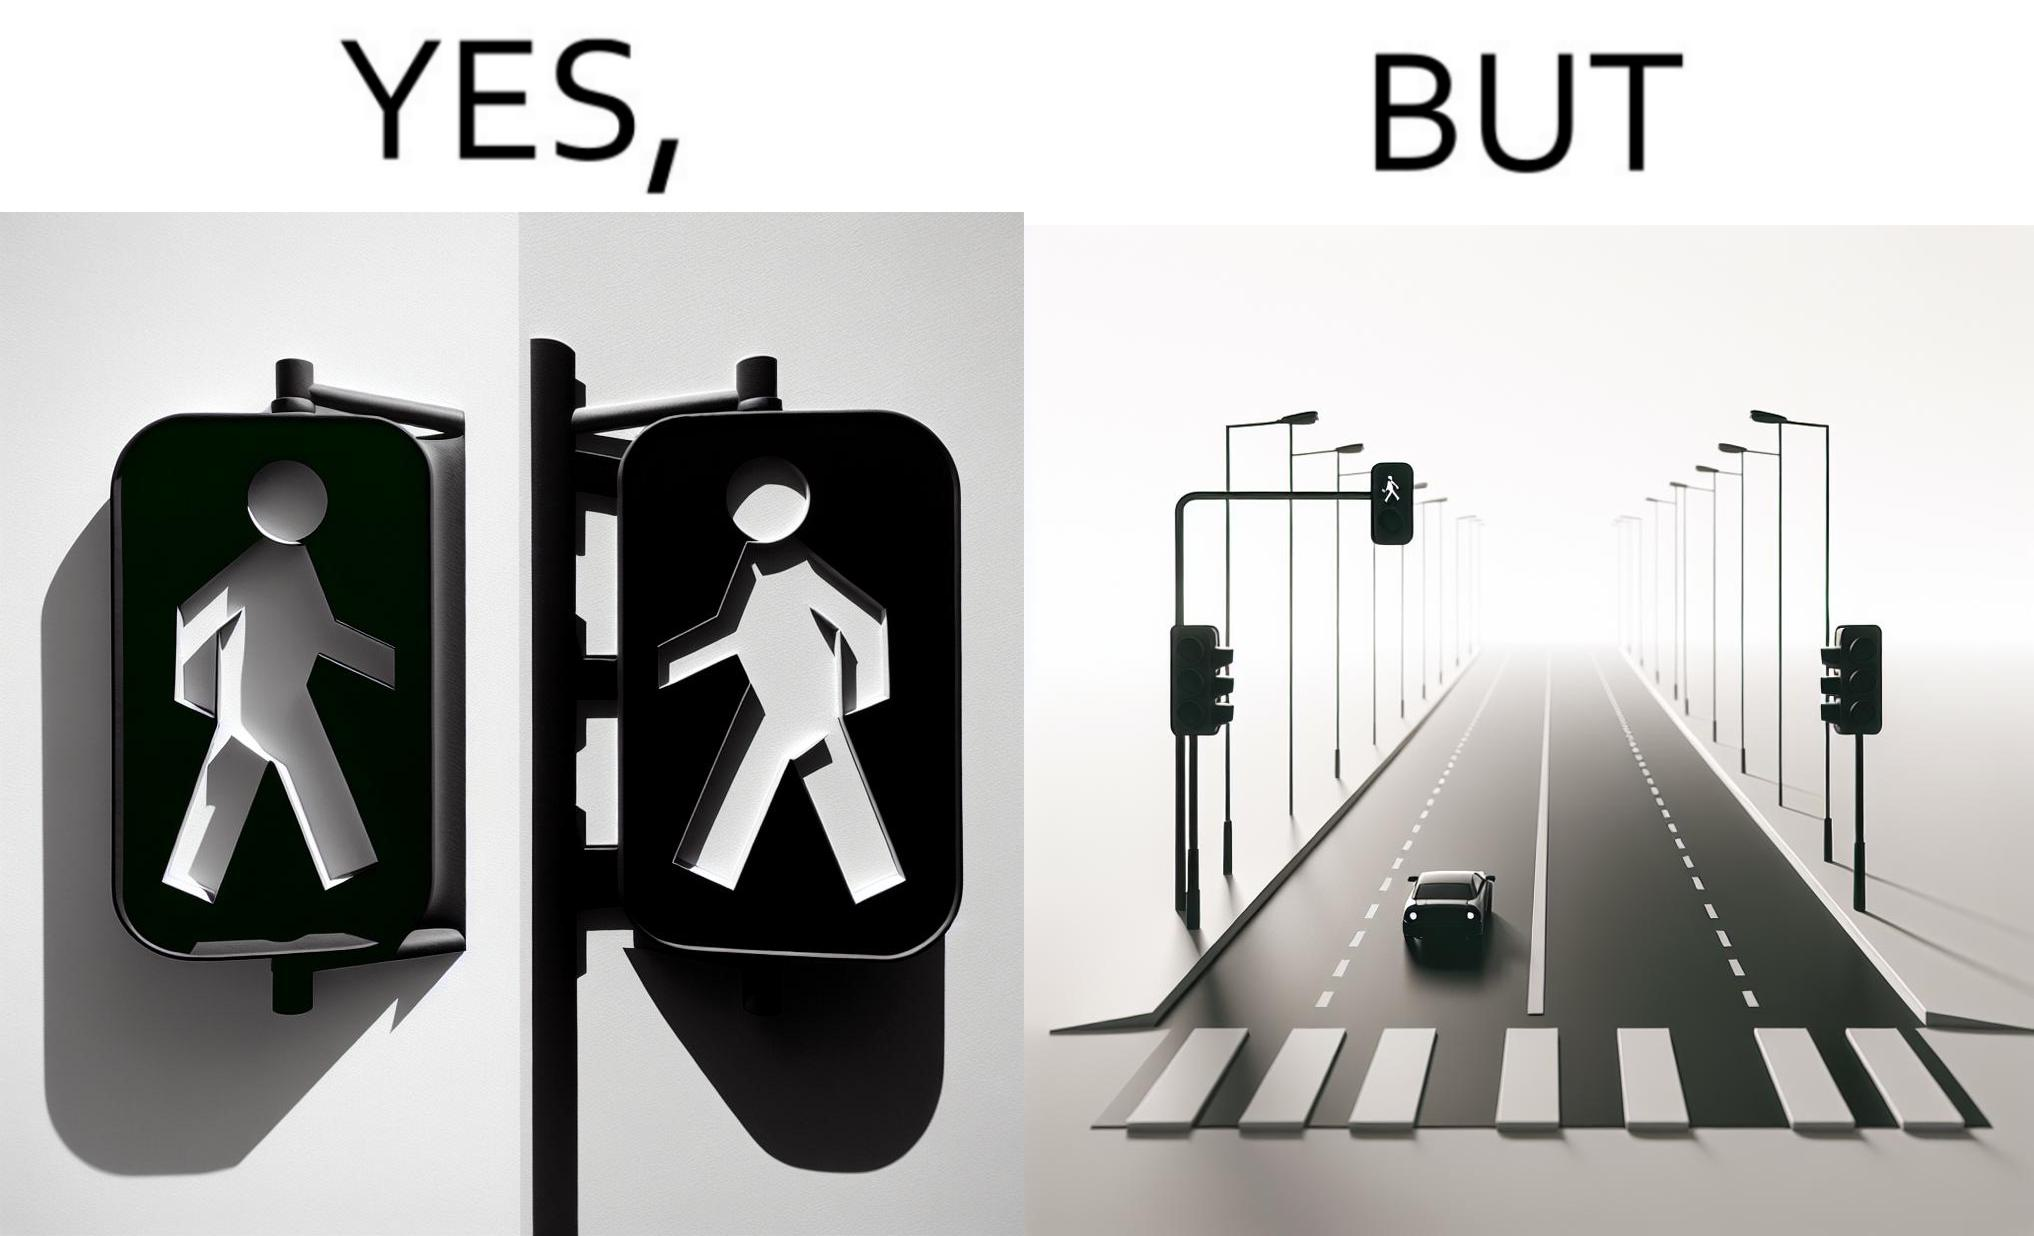Provide a description of this image. The image is funny because while walk signs are very useful for pedestrians to be able to cross roads safely, the become unnecessary and annoying for car drivers when these signals turn green even when there is no pedestrian tring to cross the road. 